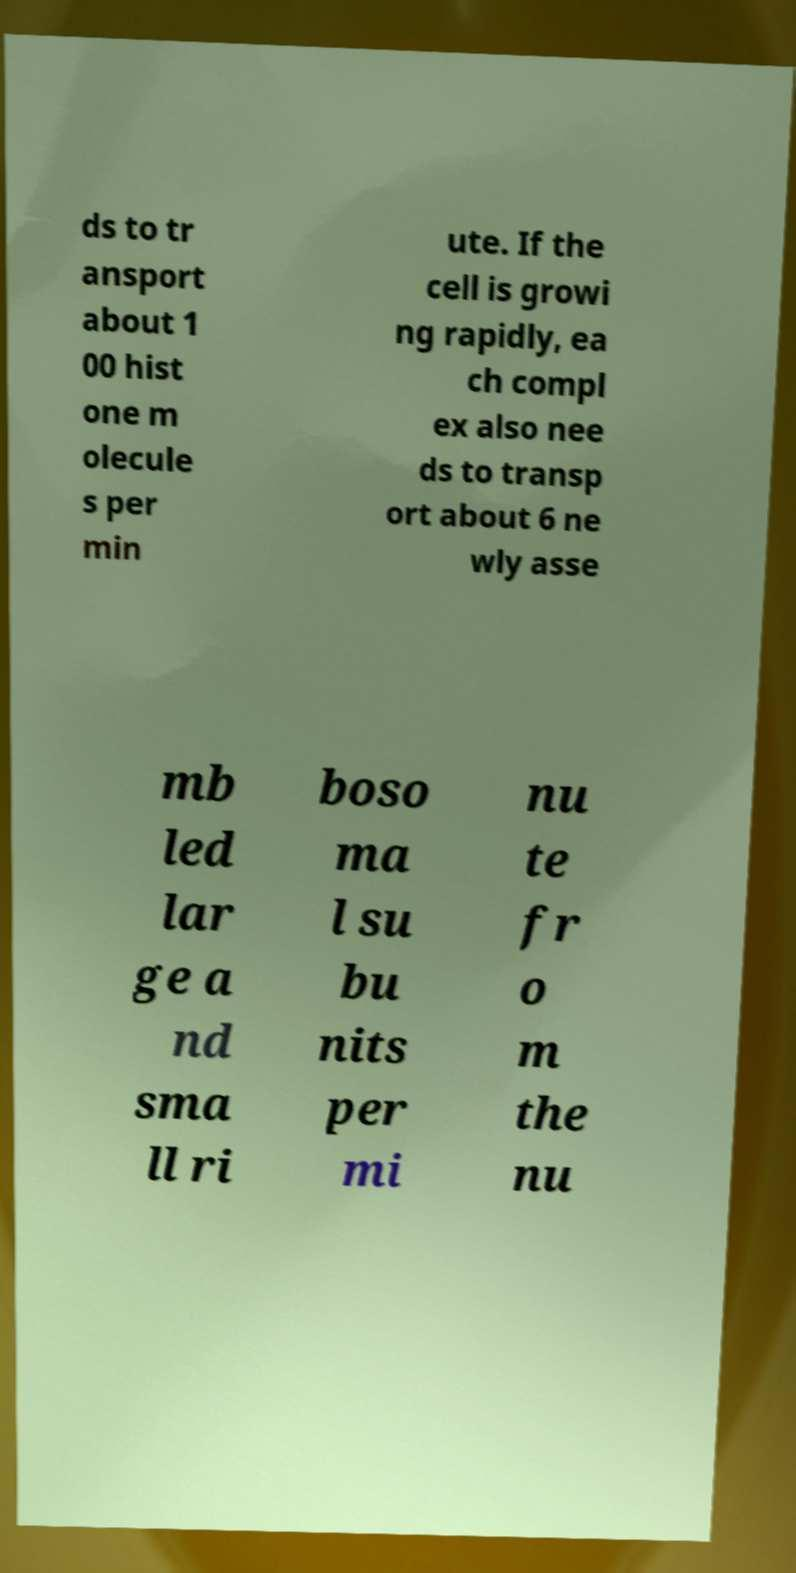Can you read and provide the text displayed in the image?This photo seems to have some interesting text. Can you extract and type it out for me? ds to tr ansport about 1 00 hist one m olecule s per min ute. If the cell is growi ng rapidly, ea ch compl ex also nee ds to transp ort about 6 ne wly asse mb led lar ge a nd sma ll ri boso ma l su bu nits per mi nu te fr o m the nu 